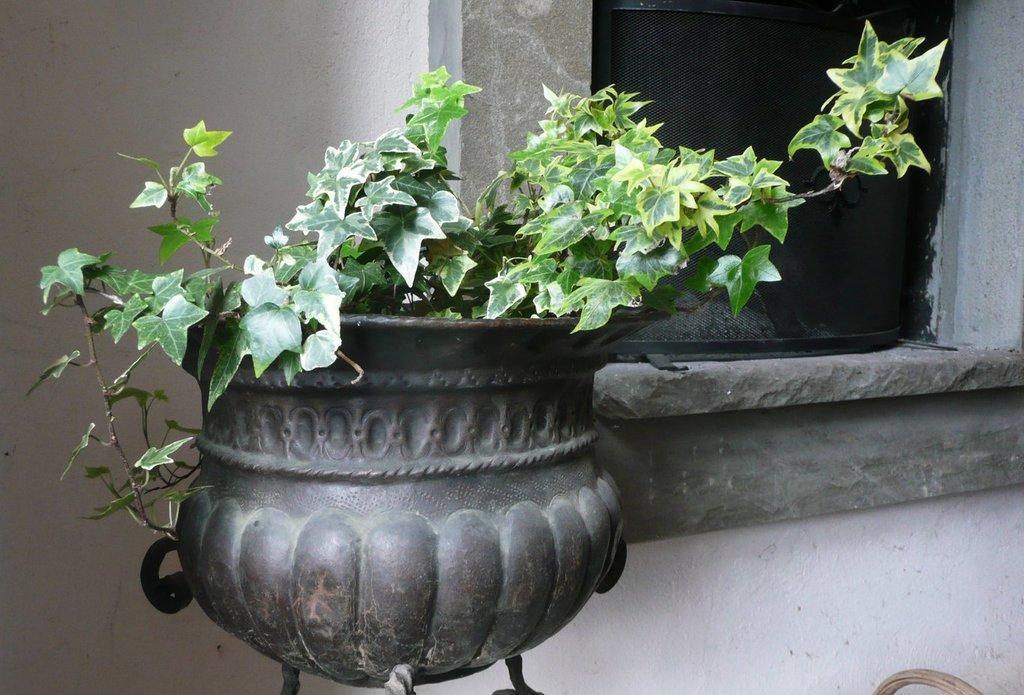Please provide a concise description of this image. In this image there is a plant in a pot , and in the background there is a wall, window. 